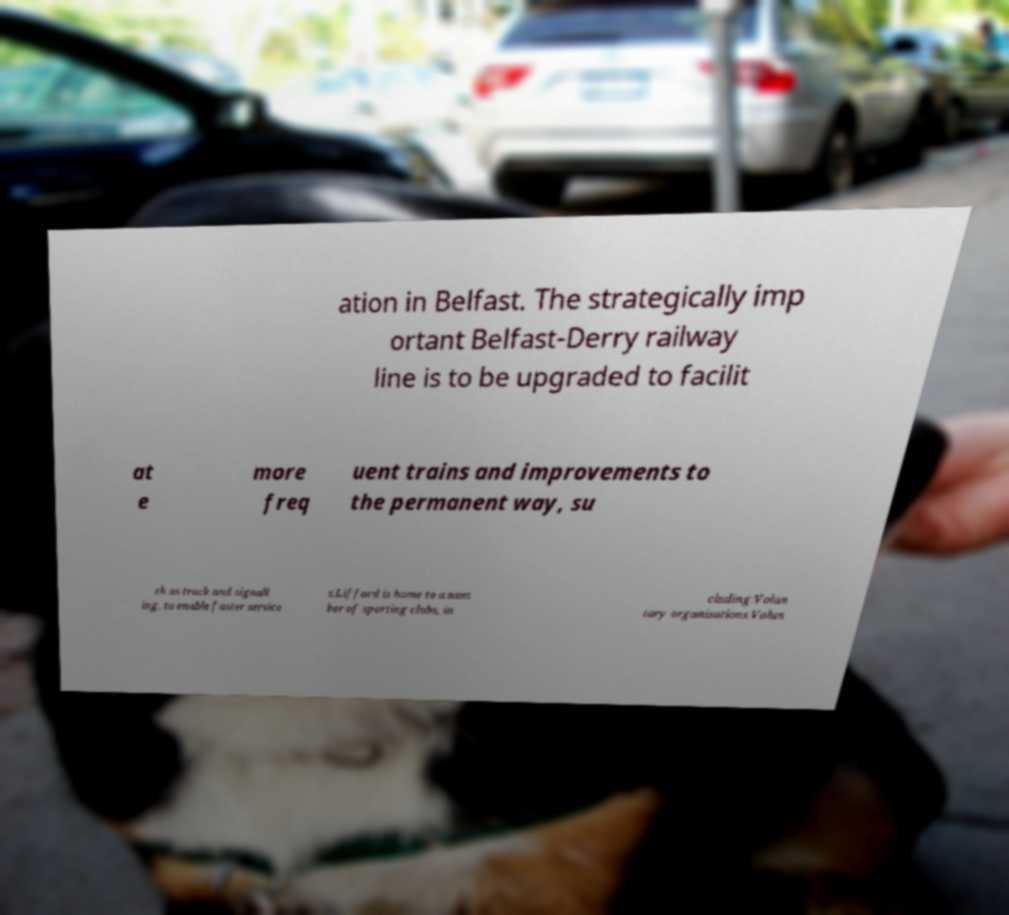Can you accurately transcribe the text from the provided image for me? ation in Belfast. The strategically imp ortant Belfast-Derry railway line is to be upgraded to facilit at e more freq uent trains and improvements to the permanent way, su ch as track and signall ing, to enable faster service s.Lifford is home to a num ber of sporting clubs, in cluding:Volun tary organisations.Volun 